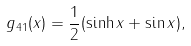<formula> <loc_0><loc_0><loc_500><loc_500>g _ { 4 1 } ( x ) = \frac { 1 } { 2 } ( \sinh x + \sin x ) ,</formula> 